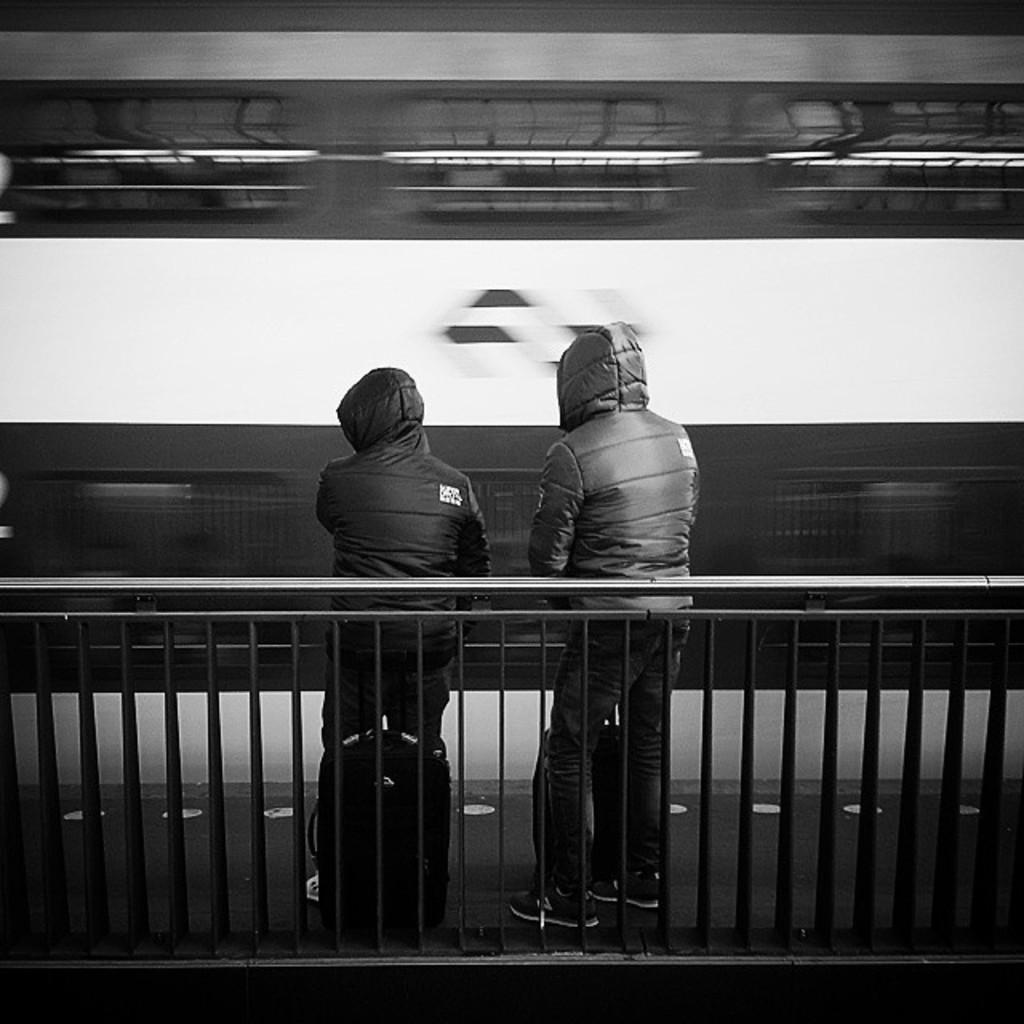In one or two sentences, can you explain what this image depicts? In this image I can see there are few persons standing in front of the fence and I can see a backpack kept on the floor. 